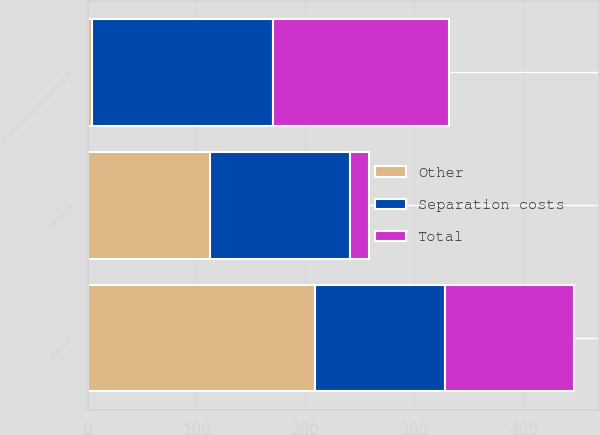Convert chart. <chart><loc_0><loc_0><loc_500><loc_500><stacked_bar_chart><ecel><fcel>Expense<fcel>Payments<fcel>Restructuring reserves as of<nl><fcel>Other<fcel>209<fcel>112<fcel>4<nl><fcel>Total<fcel>119<fcel>17<fcel>162<nl><fcel>Separation costs<fcel>119<fcel>129<fcel>166<nl></chart> 